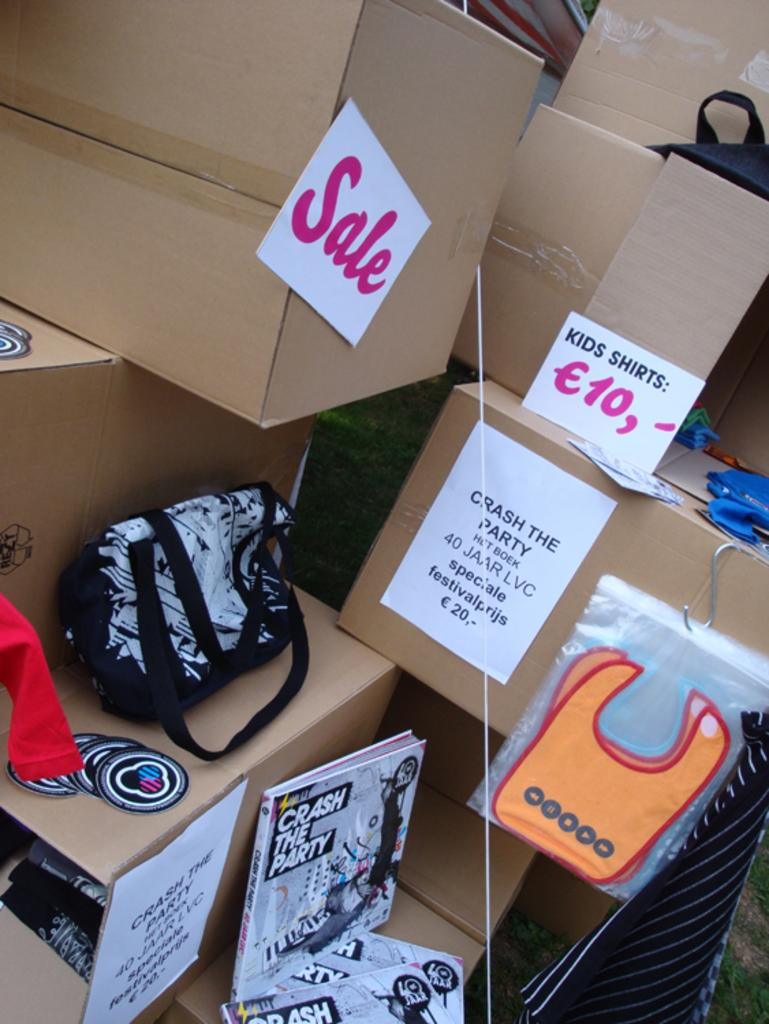<image>
Share a concise interpretation of the image provided. Boxes displaying items that are potentially for sale. 